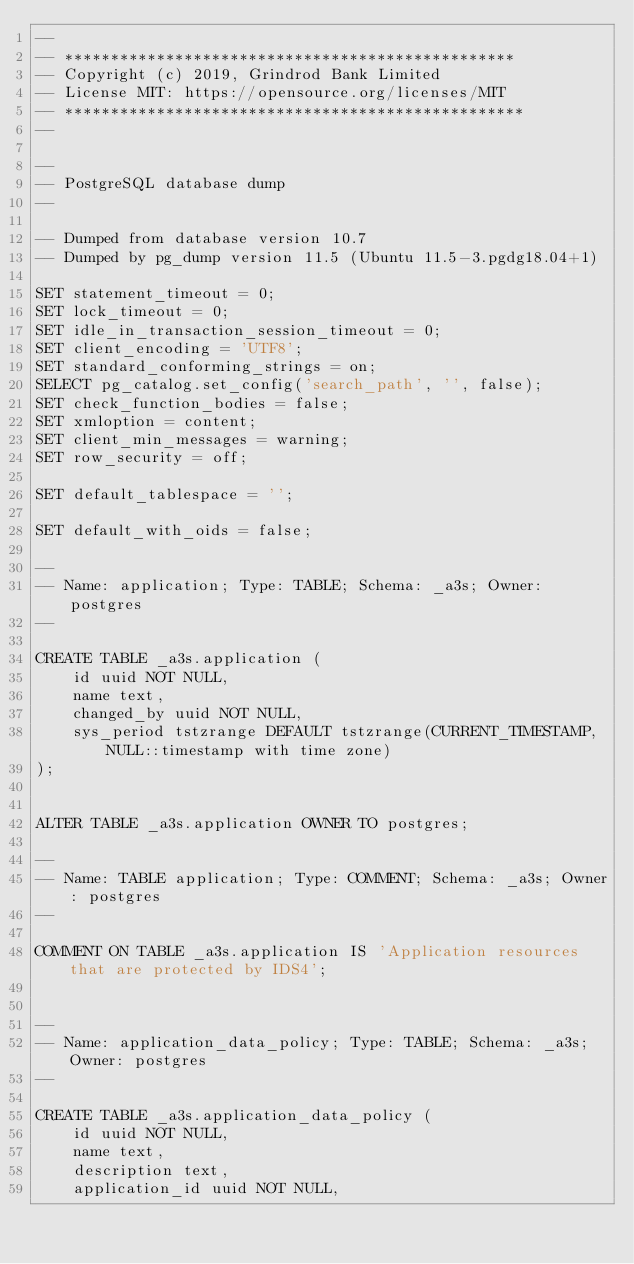<code> <loc_0><loc_0><loc_500><loc_500><_SQL_>--
-- *************************************************
-- Copyright (c) 2019, Grindrod Bank Limited
-- License MIT: https://opensource.org/licenses/MIT
-- **************************************************
--

--
-- PostgreSQL database dump
--

-- Dumped from database version 10.7
-- Dumped by pg_dump version 11.5 (Ubuntu 11.5-3.pgdg18.04+1)

SET statement_timeout = 0;
SET lock_timeout = 0;
SET idle_in_transaction_session_timeout = 0;
SET client_encoding = 'UTF8';
SET standard_conforming_strings = on;
SELECT pg_catalog.set_config('search_path', '', false);
SET check_function_bodies = false;
SET xmloption = content;
SET client_min_messages = warning;
SET row_security = off;

SET default_tablespace = '';

SET default_with_oids = false;

--
-- Name: application; Type: TABLE; Schema: _a3s; Owner: postgres
--

CREATE TABLE _a3s.application (
    id uuid NOT NULL,
    name text,
    changed_by uuid NOT NULL,
    sys_period tstzrange DEFAULT tstzrange(CURRENT_TIMESTAMP, NULL::timestamp with time zone)
);


ALTER TABLE _a3s.application OWNER TO postgres;

--
-- Name: TABLE application; Type: COMMENT; Schema: _a3s; Owner: postgres
--

COMMENT ON TABLE _a3s.application IS 'Application resources that are protected by IDS4';


--
-- Name: application_data_policy; Type: TABLE; Schema: _a3s; Owner: postgres
--

CREATE TABLE _a3s.application_data_policy (
    id uuid NOT NULL,
    name text,
    description text,
    application_id uuid NOT NULL,</code> 